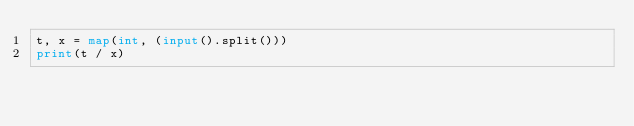Convert code to text. <code><loc_0><loc_0><loc_500><loc_500><_Python_>t, x = map(int, (input().split()))
print(t / x)</code> 